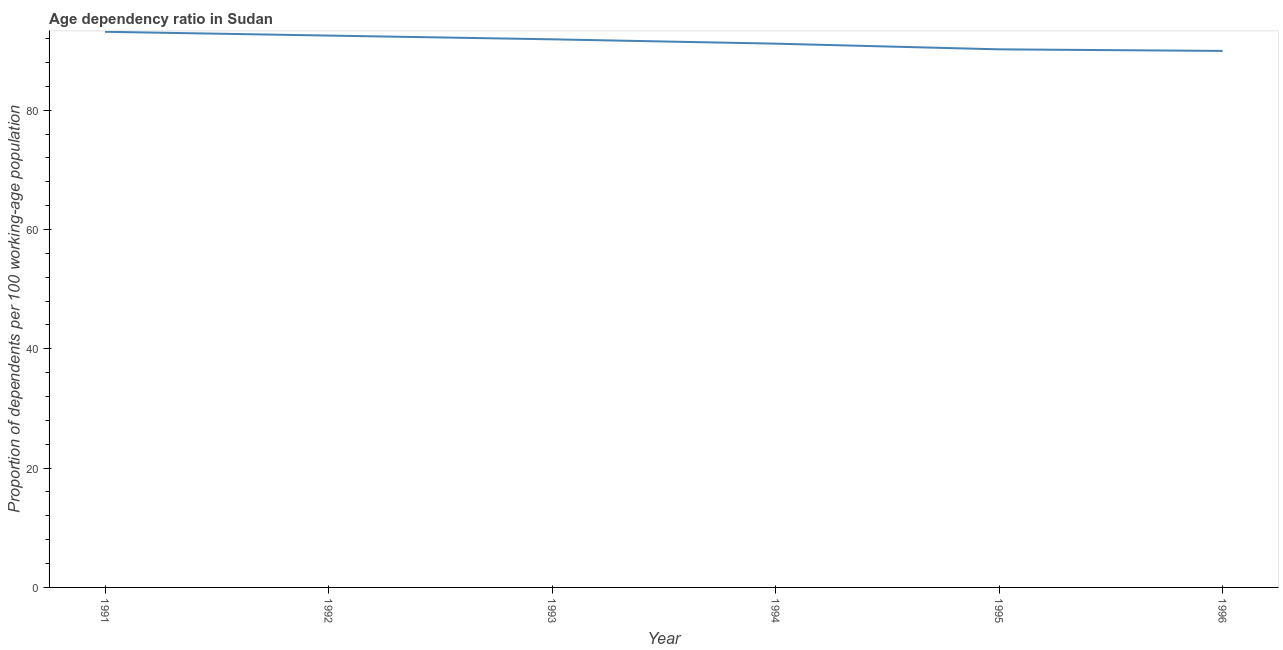What is the age dependency ratio in 1994?
Give a very brief answer. 91.15. Across all years, what is the maximum age dependency ratio?
Provide a short and direct response. 93.14. Across all years, what is the minimum age dependency ratio?
Provide a succinct answer. 89.94. In which year was the age dependency ratio maximum?
Ensure brevity in your answer.  1991. What is the sum of the age dependency ratio?
Make the answer very short. 548.82. What is the difference between the age dependency ratio in 1991 and 1993?
Keep it short and to the point. 1.26. What is the average age dependency ratio per year?
Make the answer very short. 91.47. What is the median age dependency ratio?
Offer a very short reply. 91.52. In how many years, is the age dependency ratio greater than 12 ?
Your answer should be compact. 6. Do a majority of the years between 1995 and 1996 (inclusive) have age dependency ratio greater than 56 ?
Give a very brief answer. Yes. What is the ratio of the age dependency ratio in 1993 to that in 1996?
Your answer should be compact. 1.02. What is the difference between the highest and the second highest age dependency ratio?
Provide a succinct answer. 0.64. Is the sum of the age dependency ratio in 1991 and 1992 greater than the maximum age dependency ratio across all years?
Ensure brevity in your answer.  Yes. What is the difference between the highest and the lowest age dependency ratio?
Your response must be concise. 3.21. Does the age dependency ratio monotonically increase over the years?
Offer a very short reply. No. How many lines are there?
Offer a very short reply. 1. How many years are there in the graph?
Your answer should be compact. 6. Are the values on the major ticks of Y-axis written in scientific E-notation?
Your answer should be compact. No. Does the graph contain grids?
Keep it short and to the point. No. What is the title of the graph?
Provide a short and direct response. Age dependency ratio in Sudan. What is the label or title of the X-axis?
Give a very brief answer. Year. What is the label or title of the Y-axis?
Keep it short and to the point. Proportion of dependents per 100 working-age population. What is the Proportion of dependents per 100 working-age population in 1991?
Your response must be concise. 93.14. What is the Proportion of dependents per 100 working-age population of 1992?
Offer a terse response. 92.51. What is the Proportion of dependents per 100 working-age population in 1993?
Keep it short and to the point. 91.88. What is the Proportion of dependents per 100 working-age population of 1994?
Keep it short and to the point. 91.15. What is the Proportion of dependents per 100 working-age population in 1995?
Provide a short and direct response. 90.2. What is the Proportion of dependents per 100 working-age population of 1996?
Keep it short and to the point. 89.94. What is the difference between the Proportion of dependents per 100 working-age population in 1991 and 1992?
Offer a very short reply. 0.64. What is the difference between the Proportion of dependents per 100 working-age population in 1991 and 1993?
Make the answer very short. 1.26. What is the difference between the Proportion of dependents per 100 working-age population in 1991 and 1994?
Provide a short and direct response. 1.99. What is the difference between the Proportion of dependents per 100 working-age population in 1991 and 1995?
Make the answer very short. 2.94. What is the difference between the Proportion of dependents per 100 working-age population in 1991 and 1996?
Make the answer very short. 3.21. What is the difference between the Proportion of dependents per 100 working-age population in 1992 and 1993?
Your response must be concise. 0.62. What is the difference between the Proportion of dependents per 100 working-age population in 1992 and 1994?
Your answer should be very brief. 1.35. What is the difference between the Proportion of dependents per 100 working-age population in 1992 and 1995?
Keep it short and to the point. 2.31. What is the difference between the Proportion of dependents per 100 working-age population in 1992 and 1996?
Your response must be concise. 2.57. What is the difference between the Proportion of dependents per 100 working-age population in 1993 and 1994?
Offer a very short reply. 0.73. What is the difference between the Proportion of dependents per 100 working-age population in 1993 and 1995?
Provide a succinct answer. 1.68. What is the difference between the Proportion of dependents per 100 working-age population in 1993 and 1996?
Keep it short and to the point. 1.95. What is the difference between the Proportion of dependents per 100 working-age population in 1994 and 1995?
Offer a terse response. 0.95. What is the difference between the Proportion of dependents per 100 working-age population in 1994 and 1996?
Your response must be concise. 1.22. What is the difference between the Proportion of dependents per 100 working-age population in 1995 and 1996?
Provide a short and direct response. 0.26. What is the ratio of the Proportion of dependents per 100 working-age population in 1991 to that in 1992?
Offer a very short reply. 1.01. What is the ratio of the Proportion of dependents per 100 working-age population in 1991 to that in 1994?
Provide a short and direct response. 1.02. What is the ratio of the Proportion of dependents per 100 working-age population in 1991 to that in 1995?
Provide a short and direct response. 1.03. What is the ratio of the Proportion of dependents per 100 working-age population in 1991 to that in 1996?
Give a very brief answer. 1.04. What is the ratio of the Proportion of dependents per 100 working-age population in 1992 to that in 1993?
Ensure brevity in your answer.  1.01. What is the ratio of the Proportion of dependents per 100 working-age population in 1992 to that in 1994?
Make the answer very short. 1.01. What is the ratio of the Proportion of dependents per 100 working-age population in 1992 to that in 1995?
Give a very brief answer. 1.03. What is the ratio of the Proportion of dependents per 100 working-age population in 1993 to that in 1995?
Your answer should be very brief. 1.02. What is the ratio of the Proportion of dependents per 100 working-age population in 1994 to that in 1995?
Your answer should be very brief. 1.01. What is the ratio of the Proportion of dependents per 100 working-age population in 1994 to that in 1996?
Provide a succinct answer. 1.01. What is the ratio of the Proportion of dependents per 100 working-age population in 1995 to that in 1996?
Offer a terse response. 1. 